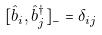Convert formula to latex. <formula><loc_0><loc_0><loc_500><loc_500>[ \hat { b } _ { i } , \hat { b } _ { j } ^ { \dagger } ] _ { - } = \delta _ { i j }</formula> 